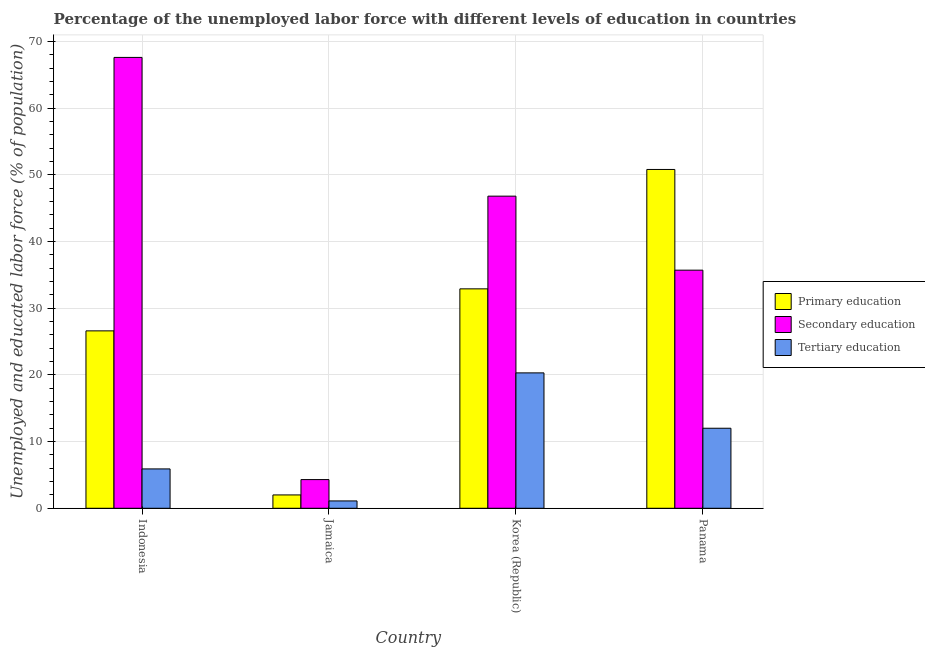Are the number of bars per tick equal to the number of legend labels?
Your response must be concise. Yes. Are the number of bars on each tick of the X-axis equal?
Ensure brevity in your answer.  Yes. How many bars are there on the 4th tick from the left?
Provide a succinct answer. 3. How many bars are there on the 4th tick from the right?
Your answer should be compact. 3. What is the label of the 4th group of bars from the left?
Give a very brief answer. Panama. In how many cases, is the number of bars for a given country not equal to the number of legend labels?
Your answer should be compact. 0. What is the percentage of labor force who received secondary education in Korea (Republic)?
Provide a short and direct response. 46.8. Across all countries, what is the maximum percentage of labor force who received primary education?
Provide a short and direct response. 50.8. Across all countries, what is the minimum percentage of labor force who received tertiary education?
Keep it short and to the point. 1.1. In which country was the percentage of labor force who received tertiary education maximum?
Keep it short and to the point. Korea (Republic). In which country was the percentage of labor force who received secondary education minimum?
Give a very brief answer. Jamaica. What is the total percentage of labor force who received primary education in the graph?
Your answer should be compact. 112.3. What is the difference between the percentage of labor force who received secondary education in Indonesia and that in Panama?
Keep it short and to the point. 31.9. What is the difference between the percentage of labor force who received tertiary education in Indonesia and the percentage of labor force who received secondary education in Panama?
Your response must be concise. -29.8. What is the average percentage of labor force who received secondary education per country?
Offer a very short reply. 38.6. What is the difference between the percentage of labor force who received secondary education and percentage of labor force who received tertiary education in Panama?
Your response must be concise. 23.7. What is the ratio of the percentage of labor force who received secondary education in Indonesia to that in Panama?
Offer a very short reply. 1.89. Is the percentage of labor force who received secondary education in Indonesia less than that in Korea (Republic)?
Your answer should be very brief. No. What is the difference between the highest and the second highest percentage of labor force who received primary education?
Your response must be concise. 17.9. What is the difference between the highest and the lowest percentage of labor force who received tertiary education?
Provide a short and direct response. 19.2. In how many countries, is the percentage of labor force who received tertiary education greater than the average percentage of labor force who received tertiary education taken over all countries?
Ensure brevity in your answer.  2. What does the 2nd bar from the left in Jamaica represents?
Provide a succinct answer. Secondary education. What does the 3rd bar from the right in Korea (Republic) represents?
Provide a short and direct response. Primary education. Is it the case that in every country, the sum of the percentage of labor force who received primary education and percentage of labor force who received secondary education is greater than the percentage of labor force who received tertiary education?
Your answer should be very brief. Yes. Are all the bars in the graph horizontal?
Your answer should be compact. No. What is the difference between two consecutive major ticks on the Y-axis?
Ensure brevity in your answer.  10. Are the values on the major ticks of Y-axis written in scientific E-notation?
Give a very brief answer. No. Does the graph contain any zero values?
Offer a very short reply. No. Does the graph contain grids?
Your answer should be very brief. Yes. How many legend labels are there?
Your answer should be compact. 3. How are the legend labels stacked?
Your answer should be very brief. Vertical. What is the title of the graph?
Give a very brief answer. Percentage of the unemployed labor force with different levels of education in countries. Does "Central government" appear as one of the legend labels in the graph?
Your answer should be compact. No. What is the label or title of the X-axis?
Ensure brevity in your answer.  Country. What is the label or title of the Y-axis?
Ensure brevity in your answer.  Unemployed and educated labor force (% of population). What is the Unemployed and educated labor force (% of population) in Primary education in Indonesia?
Provide a short and direct response. 26.6. What is the Unemployed and educated labor force (% of population) in Secondary education in Indonesia?
Offer a very short reply. 67.6. What is the Unemployed and educated labor force (% of population) of Tertiary education in Indonesia?
Provide a short and direct response. 5.9. What is the Unemployed and educated labor force (% of population) in Primary education in Jamaica?
Ensure brevity in your answer.  2. What is the Unemployed and educated labor force (% of population) in Secondary education in Jamaica?
Offer a terse response. 4.3. What is the Unemployed and educated labor force (% of population) in Tertiary education in Jamaica?
Your answer should be very brief. 1.1. What is the Unemployed and educated labor force (% of population) of Primary education in Korea (Republic)?
Offer a terse response. 32.9. What is the Unemployed and educated labor force (% of population) in Secondary education in Korea (Republic)?
Provide a short and direct response. 46.8. What is the Unemployed and educated labor force (% of population) of Tertiary education in Korea (Republic)?
Your response must be concise. 20.3. What is the Unemployed and educated labor force (% of population) of Primary education in Panama?
Offer a terse response. 50.8. What is the Unemployed and educated labor force (% of population) in Secondary education in Panama?
Your response must be concise. 35.7. What is the Unemployed and educated labor force (% of population) of Tertiary education in Panama?
Provide a short and direct response. 12. Across all countries, what is the maximum Unemployed and educated labor force (% of population) in Primary education?
Provide a succinct answer. 50.8. Across all countries, what is the maximum Unemployed and educated labor force (% of population) in Secondary education?
Make the answer very short. 67.6. Across all countries, what is the maximum Unemployed and educated labor force (% of population) in Tertiary education?
Your response must be concise. 20.3. Across all countries, what is the minimum Unemployed and educated labor force (% of population) in Primary education?
Make the answer very short. 2. Across all countries, what is the minimum Unemployed and educated labor force (% of population) in Secondary education?
Your answer should be compact. 4.3. Across all countries, what is the minimum Unemployed and educated labor force (% of population) of Tertiary education?
Your response must be concise. 1.1. What is the total Unemployed and educated labor force (% of population) in Primary education in the graph?
Your answer should be very brief. 112.3. What is the total Unemployed and educated labor force (% of population) in Secondary education in the graph?
Provide a short and direct response. 154.4. What is the total Unemployed and educated labor force (% of population) of Tertiary education in the graph?
Provide a succinct answer. 39.3. What is the difference between the Unemployed and educated labor force (% of population) of Primary education in Indonesia and that in Jamaica?
Make the answer very short. 24.6. What is the difference between the Unemployed and educated labor force (% of population) in Secondary education in Indonesia and that in Jamaica?
Keep it short and to the point. 63.3. What is the difference between the Unemployed and educated labor force (% of population) of Tertiary education in Indonesia and that in Jamaica?
Provide a succinct answer. 4.8. What is the difference between the Unemployed and educated labor force (% of population) in Primary education in Indonesia and that in Korea (Republic)?
Your response must be concise. -6.3. What is the difference between the Unemployed and educated labor force (% of population) of Secondary education in Indonesia and that in Korea (Republic)?
Offer a very short reply. 20.8. What is the difference between the Unemployed and educated labor force (% of population) of Tertiary education in Indonesia and that in Korea (Republic)?
Your response must be concise. -14.4. What is the difference between the Unemployed and educated labor force (% of population) of Primary education in Indonesia and that in Panama?
Your answer should be very brief. -24.2. What is the difference between the Unemployed and educated labor force (% of population) of Secondary education in Indonesia and that in Panama?
Make the answer very short. 31.9. What is the difference between the Unemployed and educated labor force (% of population) in Tertiary education in Indonesia and that in Panama?
Provide a short and direct response. -6.1. What is the difference between the Unemployed and educated labor force (% of population) in Primary education in Jamaica and that in Korea (Republic)?
Provide a short and direct response. -30.9. What is the difference between the Unemployed and educated labor force (% of population) in Secondary education in Jamaica and that in Korea (Republic)?
Provide a succinct answer. -42.5. What is the difference between the Unemployed and educated labor force (% of population) of Tertiary education in Jamaica and that in Korea (Republic)?
Offer a very short reply. -19.2. What is the difference between the Unemployed and educated labor force (% of population) in Primary education in Jamaica and that in Panama?
Offer a terse response. -48.8. What is the difference between the Unemployed and educated labor force (% of population) in Secondary education in Jamaica and that in Panama?
Keep it short and to the point. -31.4. What is the difference between the Unemployed and educated labor force (% of population) of Tertiary education in Jamaica and that in Panama?
Give a very brief answer. -10.9. What is the difference between the Unemployed and educated labor force (% of population) of Primary education in Korea (Republic) and that in Panama?
Provide a short and direct response. -17.9. What is the difference between the Unemployed and educated labor force (% of population) of Secondary education in Korea (Republic) and that in Panama?
Keep it short and to the point. 11.1. What is the difference between the Unemployed and educated labor force (% of population) in Tertiary education in Korea (Republic) and that in Panama?
Provide a short and direct response. 8.3. What is the difference between the Unemployed and educated labor force (% of population) of Primary education in Indonesia and the Unemployed and educated labor force (% of population) of Secondary education in Jamaica?
Make the answer very short. 22.3. What is the difference between the Unemployed and educated labor force (% of population) of Primary education in Indonesia and the Unemployed and educated labor force (% of population) of Tertiary education in Jamaica?
Your response must be concise. 25.5. What is the difference between the Unemployed and educated labor force (% of population) of Secondary education in Indonesia and the Unemployed and educated labor force (% of population) of Tertiary education in Jamaica?
Your response must be concise. 66.5. What is the difference between the Unemployed and educated labor force (% of population) of Primary education in Indonesia and the Unemployed and educated labor force (% of population) of Secondary education in Korea (Republic)?
Your answer should be very brief. -20.2. What is the difference between the Unemployed and educated labor force (% of population) of Primary education in Indonesia and the Unemployed and educated labor force (% of population) of Tertiary education in Korea (Republic)?
Provide a succinct answer. 6.3. What is the difference between the Unemployed and educated labor force (% of population) in Secondary education in Indonesia and the Unemployed and educated labor force (% of population) in Tertiary education in Korea (Republic)?
Offer a very short reply. 47.3. What is the difference between the Unemployed and educated labor force (% of population) of Primary education in Indonesia and the Unemployed and educated labor force (% of population) of Secondary education in Panama?
Keep it short and to the point. -9.1. What is the difference between the Unemployed and educated labor force (% of population) in Primary education in Indonesia and the Unemployed and educated labor force (% of population) in Tertiary education in Panama?
Your answer should be very brief. 14.6. What is the difference between the Unemployed and educated labor force (% of population) of Secondary education in Indonesia and the Unemployed and educated labor force (% of population) of Tertiary education in Panama?
Offer a terse response. 55.6. What is the difference between the Unemployed and educated labor force (% of population) in Primary education in Jamaica and the Unemployed and educated labor force (% of population) in Secondary education in Korea (Republic)?
Offer a terse response. -44.8. What is the difference between the Unemployed and educated labor force (% of population) of Primary education in Jamaica and the Unemployed and educated labor force (% of population) of Tertiary education in Korea (Republic)?
Your response must be concise. -18.3. What is the difference between the Unemployed and educated labor force (% of population) in Secondary education in Jamaica and the Unemployed and educated labor force (% of population) in Tertiary education in Korea (Republic)?
Your answer should be very brief. -16. What is the difference between the Unemployed and educated labor force (% of population) in Primary education in Jamaica and the Unemployed and educated labor force (% of population) in Secondary education in Panama?
Your answer should be compact. -33.7. What is the difference between the Unemployed and educated labor force (% of population) of Primary education in Jamaica and the Unemployed and educated labor force (% of population) of Tertiary education in Panama?
Provide a succinct answer. -10. What is the difference between the Unemployed and educated labor force (% of population) of Primary education in Korea (Republic) and the Unemployed and educated labor force (% of population) of Tertiary education in Panama?
Offer a terse response. 20.9. What is the difference between the Unemployed and educated labor force (% of population) in Secondary education in Korea (Republic) and the Unemployed and educated labor force (% of population) in Tertiary education in Panama?
Keep it short and to the point. 34.8. What is the average Unemployed and educated labor force (% of population) of Primary education per country?
Provide a short and direct response. 28.07. What is the average Unemployed and educated labor force (% of population) in Secondary education per country?
Offer a very short reply. 38.6. What is the average Unemployed and educated labor force (% of population) in Tertiary education per country?
Your response must be concise. 9.82. What is the difference between the Unemployed and educated labor force (% of population) in Primary education and Unemployed and educated labor force (% of population) in Secondary education in Indonesia?
Keep it short and to the point. -41. What is the difference between the Unemployed and educated labor force (% of population) of Primary education and Unemployed and educated labor force (% of population) of Tertiary education in Indonesia?
Provide a succinct answer. 20.7. What is the difference between the Unemployed and educated labor force (% of population) in Secondary education and Unemployed and educated labor force (% of population) in Tertiary education in Indonesia?
Offer a very short reply. 61.7. What is the difference between the Unemployed and educated labor force (% of population) in Primary education and Unemployed and educated labor force (% of population) in Secondary education in Jamaica?
Provide a succinct answer. -2.3. What is the difference between the Unemployed and educated labor force (% of population) of Secondary education and Unemployed and educated labor force (% of population) of Tertiary education in Jamaica?
Provide a short and direct response. 3.2. What is the difference between the Unemployed and educated labor force (% of population) in Primary education and Unemployed and educated labor force (% of population) in Secondary education in Korea (Republic)?
Keep it short and to the point. -13.9. What is the difference between the Unemployed and educated labor force (% of population) of Primary education and Unemployed and educated labor force (% of population) of Tertiary education in Korea (Republic)?
Offer a terse response. 12.6. What is the difference between the Unemployed and educated labor force (% of population) in Secondary education and Unemployed and educated labor force (% of population) in Tertiary education in Korea (Republic)?
Your answer should be compact. 26.5. What is the difference between the Unemployed and educated labor force (% of population) in Primary education and Unemployed and educated labor force (% of population) in Tertiary education in Panama?
Make the answer very short. 38.8. What is the difference between the Unemployed and educated labor force (% of population) in Secondary education and Unemployed and educated labor force (% of population) in Tertiary education in Panama?
Keep it short and to the point. 23.7. What is the ratio of the Unemployed and educated labor force (% of population) in Primary education in Indonesia to that in Jamaica?
Your answer should be very brief. 13.3. What is the ratio of the Unemployed and educated labor force (% of population) of Secondary education in Indonesia to that in Jamaica?
Offer a very short reply. 15.72. What is the ratio of the Unemployed and educated labor force (% of population) in Tertiary education in Indonesia to that in Jamaica?
Your answer should be very brief. 5.36. What is the ratio of the Unemployed and educated labor force (% of population) of Primary education in Indonesia to that in Korea (Republic)?
Ensure brevity in your answer.  0.81. What is the ratio of the Unemployed and educated labor force (% of population) of Secondary education in Indonesia to that in Korea (Republic)?
Keep it short and to the point. 1.44. What is the ratio of the Unemployed and educated labor force (% of population) of Tertiary education in Indonesia to that in Korea (Republic)?
Offer a terse response. 0.29. What is the ratio of the Unemployed and educated labor force (% of population) of Primary education in Indonesia to that in Panama?
Provide a succinct answer. 0.52. What is the ratio of the Unemployed and educated labor force (% of population) in Secondary education in Indonesia to that in Panama?
Your response must be concise. 1.89. What is the ratio of the Unemployed and educated labor force (% of population) in Tertiary education in Indonesia to that in Panama?
Ensure brevity in your answer.  0.49. What is the ratio of the Unemployed and educated labor force (% of population) in Primary education in Jamaica to that in Korea (Republic)?
Your answer should be very brief. 0.06. What is the ratio of the Unemployed and educated labor force (% of population) of Secondary education in Jamaica to that in Korea (Republic)?
Provide a succinct answer. 0.09. What is the ratio of the Unemployed and educated labor force (% of population) of Tertiary education in Jamaica to that in Korea (Republic)?
Provide a succinct answer. 0.05. What is the ratio of the Unemployed and educated labor force (% of population) of Primary education in Jamaica to that in Panama?
Provide a short and direct response. 0.04. What is the ratio of the Unemployed and educated labor force (% of population) in Secondary education in Jamaica to that in Panama?
Provide a succinct answer. 0.12. What is the ratio of the Unemployed and educated labor force (% of population) in Tertiary education in Jamaica to that in Panama?
Your answer should be compact. 0.09. What is the ratio of the Unemployed and educated labor force (% of population) of Primary education in Korea (Republic) to that in Panama?
Your response must be concise. 0.65. What is the ratio of the Unemployed and educated labor force (% of population) of Secondary education in Korea (Republic) to that in Panama?
Keep it short and to the point. 1.31. What is the ratio of the Unemployed and educated labor force (% of population) in Tertiary education in Korea (Republic) to that in Panama?
Offer a terse response. 1.69. What is the difference between the highest and the second highest Unemployed and educated labor force (% of population) of Primary education?
Make the answer very short. 17.9. What is the difference between the highest and the second highest Unemployed and educated labor force (% of population) in Secondary education?
Provide a short and direct response. 20.8. What is the difference between the highest and the lowest Unemployed and educated labor force (% of population) in Primary education?
Offer a very short reply. 48.8. What is the difference between the highest and the lowest Unemployed and educated labor force (% of population) of Secondary education?
Make the answer very short. 63.3. What is the difference between the highest and the lowest Unemployed and educated labor force (% of population) of Tertiary education?
Make the answer very short. 19.2. 